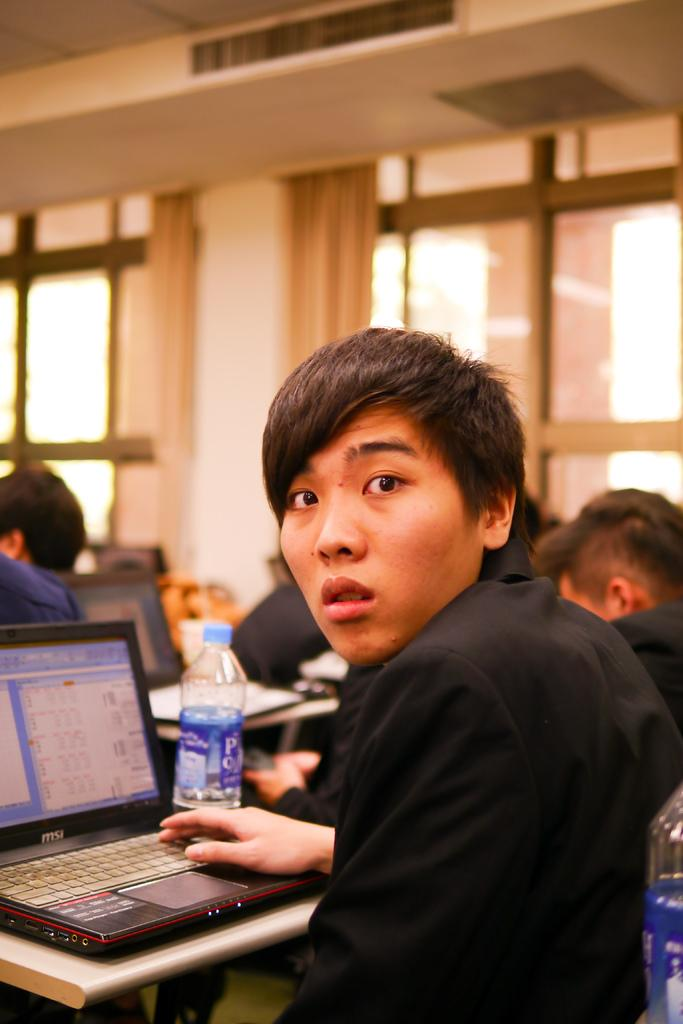What is the main subject in the center of the image? There is a person in the center of the image. What is the person doing in the image? The person is working on a laptop. Where is the laptop located in the image? The laptop is on a table. How many people are visible in the image? There are a few people in the image. What type of architectural feature can be seen in the image? There is a glass window in the window in the image. What type of stocking is the person wearing in the image? There is no information about the person's clothing, including stockings, in the image. Can you see any toys in the image? There are no toys visible in the image. 